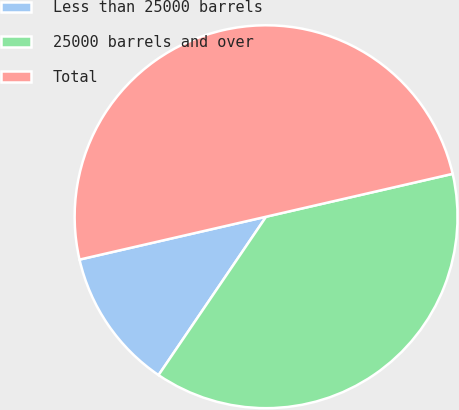Convert chart to OTSL. <chart><loc_0><loc_0><loc_500><loc_500><pie_chart><fcel>Less than 25000 barrels<fcel>25000 barrels and over<fcel>Total<nl><fcel>11.91%<fcel>38.09%<fcel>50.0%<nl></chart> 